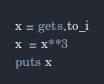<code> <loc_0><loc_0><loc_500><loc_500><_Ruby_>x = gets.to_i
x  = x**3
puts x</code> 